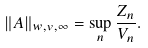<formula> <loc_0><loc_0><loc_500><loc_500>\| A \| _ { w , v , \infty } & = \sup _ { n } \frac { Z _ { n } } { V _ { n } } .</formula> 